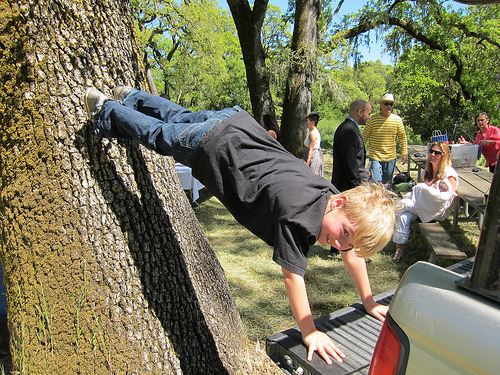<image>
Can you confirm if the boy is next to the shadow? Yes. The boy is positioned adjacent to the shadow, located nearby in the same general area. 